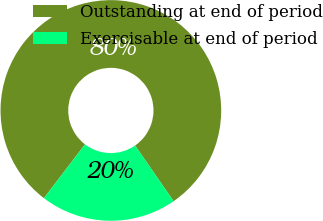<chart> <loc_0><loc_0><loc_500><loc_500><pie_chart><fcel>Outstanding at end of period<fcel>Exercisable at end of period<nl><fcel>80.0%<fcel>20.0%<nl></chart> 